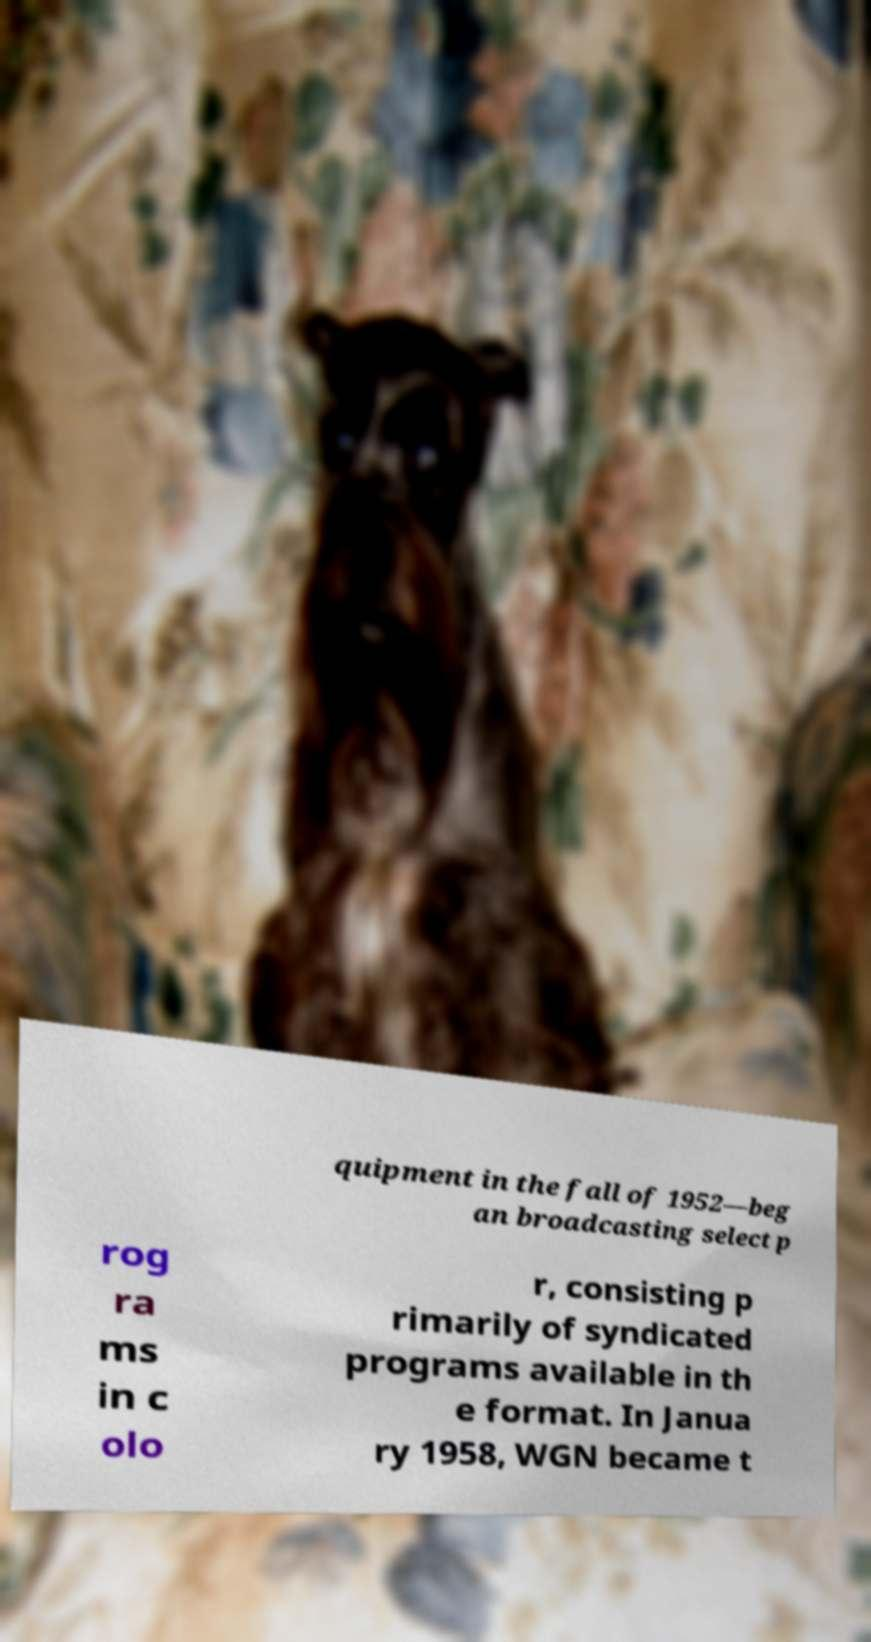Can you accurately transcribe the text from the provided image for me? quipment in the fall of 1952—beg an broadcasting select p rog ra ms in c olo r, consisting p rimarily of syndicated programs available in th e format. In Janua ry 1958, WGN became t 